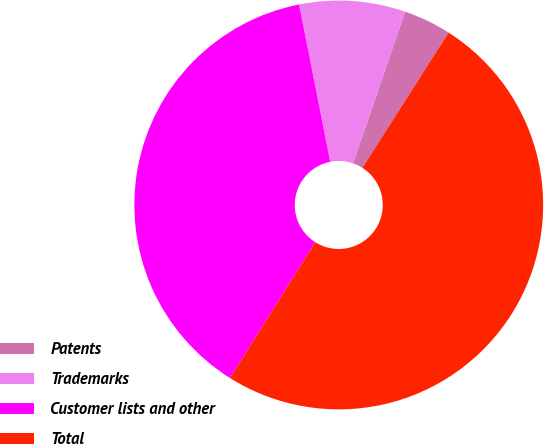Convert chart to OTSL. <chart><loc_0><loc_0><loc_500><loc_500><pie_chart><fcel>Patents<fcel>Trademarks<fcel>Customer lists and other<fcel>Total<nl><fcel>3.76%<fcel>8.37%<fcel>37.96%<fcel>49.91%<nl></chart> 